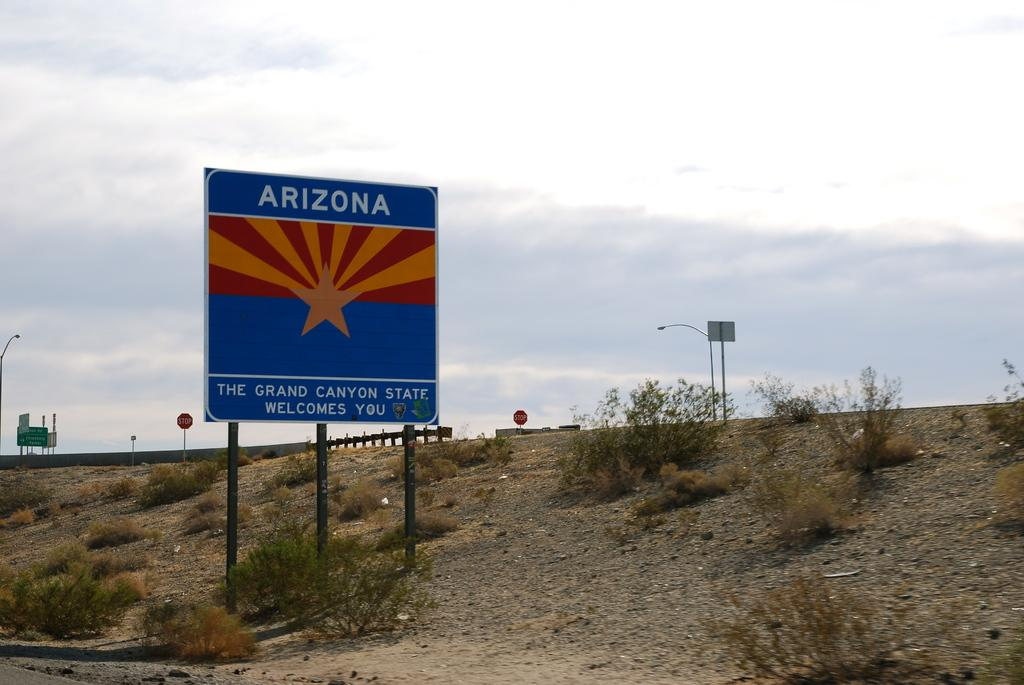<image>
Describe the image concisely. a large blue sign on the roadside welcoming you to Arizona 